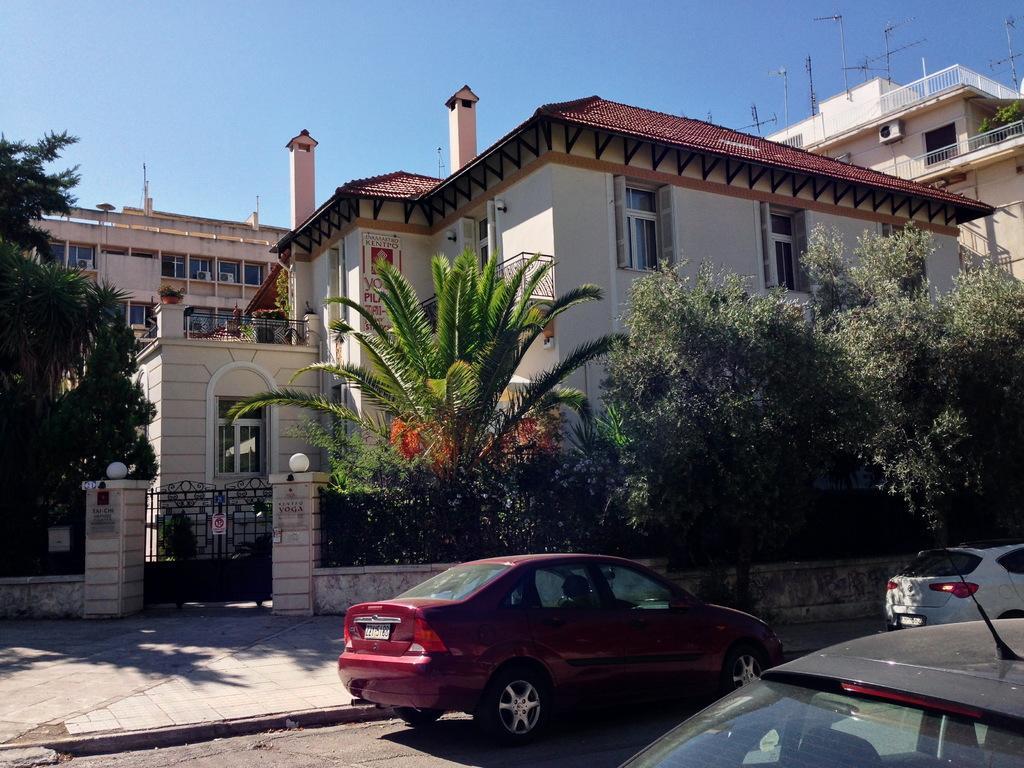Could you give a brief overview of what you see in this image? In this image I can see few vehicles, in front the vehicle is in red color. Background I can see trees in green color, building in cream and maroon color and sky in blue color. 